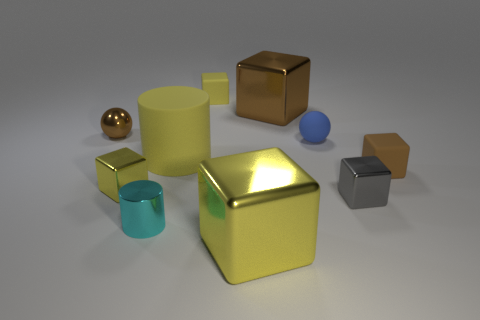Are there any cyan rubber cylinders?
Give a very brief answer. No. There is a sphere that is made of the same material as the tiny cyan object; what is its size?
Offer a terse response. Small. There is a yellow rubber object that is in front of the small sphere that is on the left side of the large metal block behind the gray shiny object; what shape is it?
Provide a succinct answer. Cylinder. Is the number of large brown things that are on the left side of the cyan cylinder the same as the number of cyan metallic cylinders?
Give a very brief answer. No. There is a metallic cube that is the same color as the metal ball; what is its size?
Your answer should be very brief. Large. Do the small gray metallic object and the small brown matte object have the same shape?
Keep it short and to the point. Yes. What number of objects are brown metallic cubes to the left of the tiny blue object or cylinders?
Give a very brief answer. 3. Are there the same number of cyan cylinders that are to the right of the blue rubber thing and big yellow rubber cylinders that are in front of the brown rubber object?
Give a very brief answer. Yes. What number of other things are there of the same shape as the tiny cyan metal thing?
Offer a terse response. 1. There is a cyan metallic object that is in front of the gray thing; is it the same size as the brown cube behind the brown rubber thing?
Offer a terse response. No. 